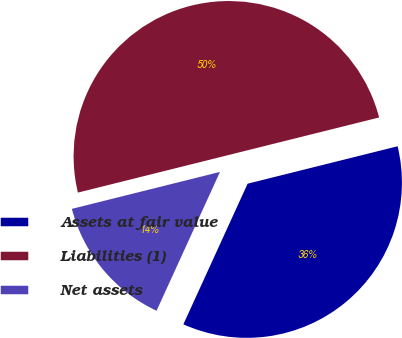<chart> <loc_0><loc_0><loc_500><loc_500><pie_chart><fcel>Assets at fair value<fcel>Liabilities (1)<fcel>Net assets<nl><fcel>35.71%<fcel>50.0%<fcel>14.29%<nl></chart> 